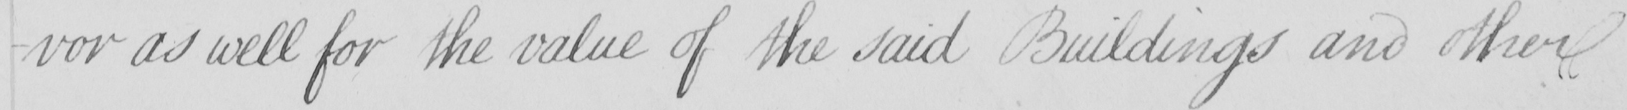Can you tell me what this handwritten text says? -vor as well for the value of the said Buildings and other 